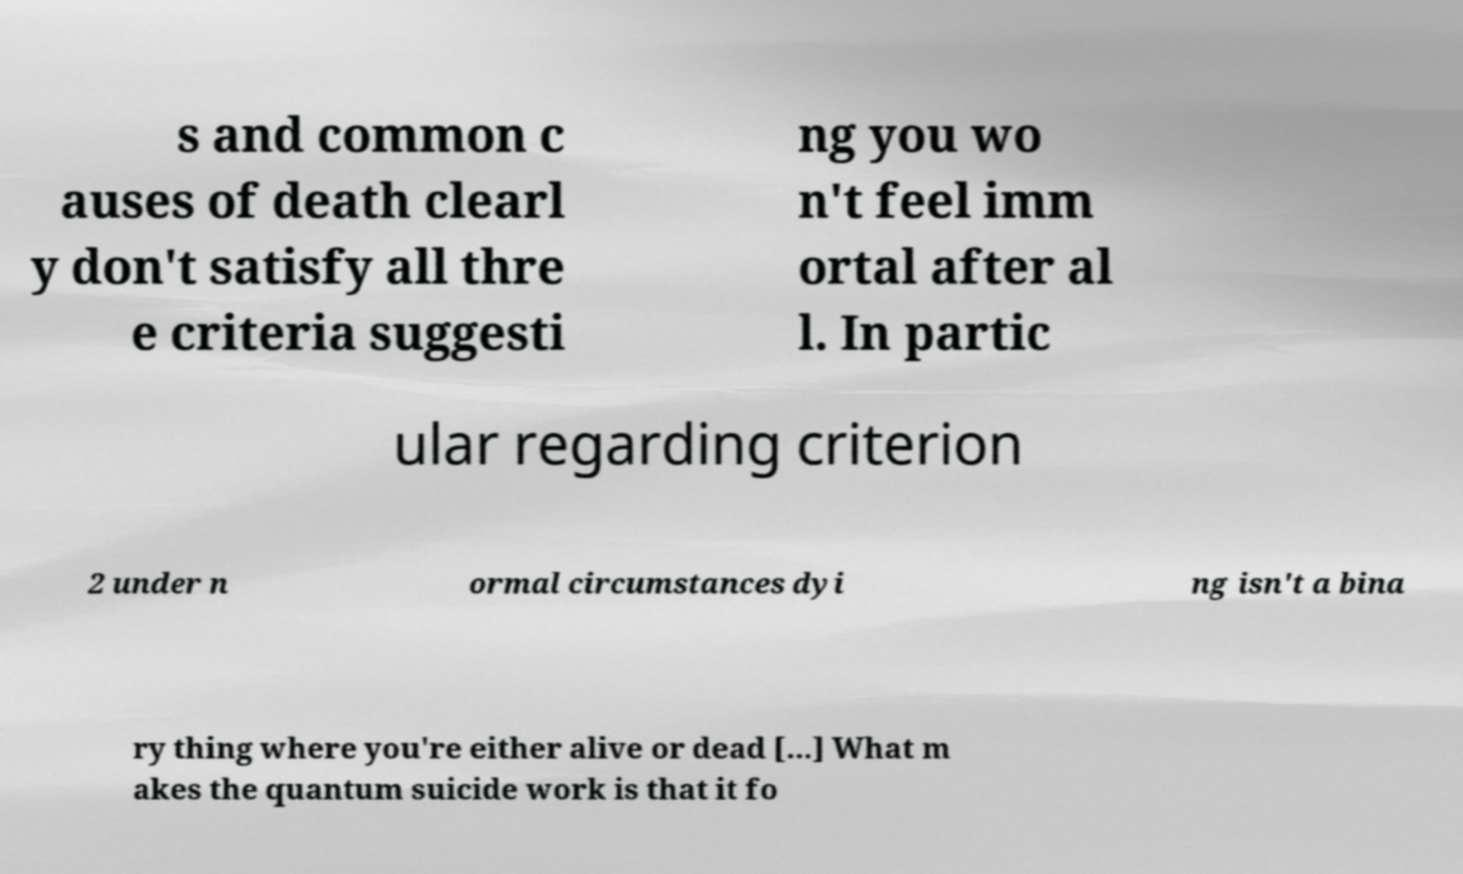Could you assist in decoding the text presented in this image and type it out clearly? s and common c auses of death clearl y don't satisfy all thre e criteria suggesti ng you wo n't feel imm ortal after al l. In partic ular regarding criterion 2 under n ormal circumstances dyi ng isn't a bina ry thing where you're either alive or dead [...] What m akes the quantum suicide work is that it fo 